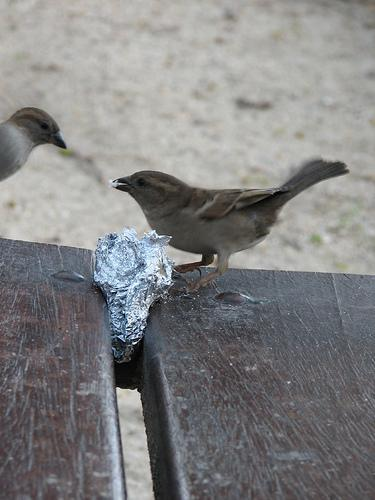What is tinfoil made of?

Choices:
A) tin
B) plastic
C) steel
D) copper tin 